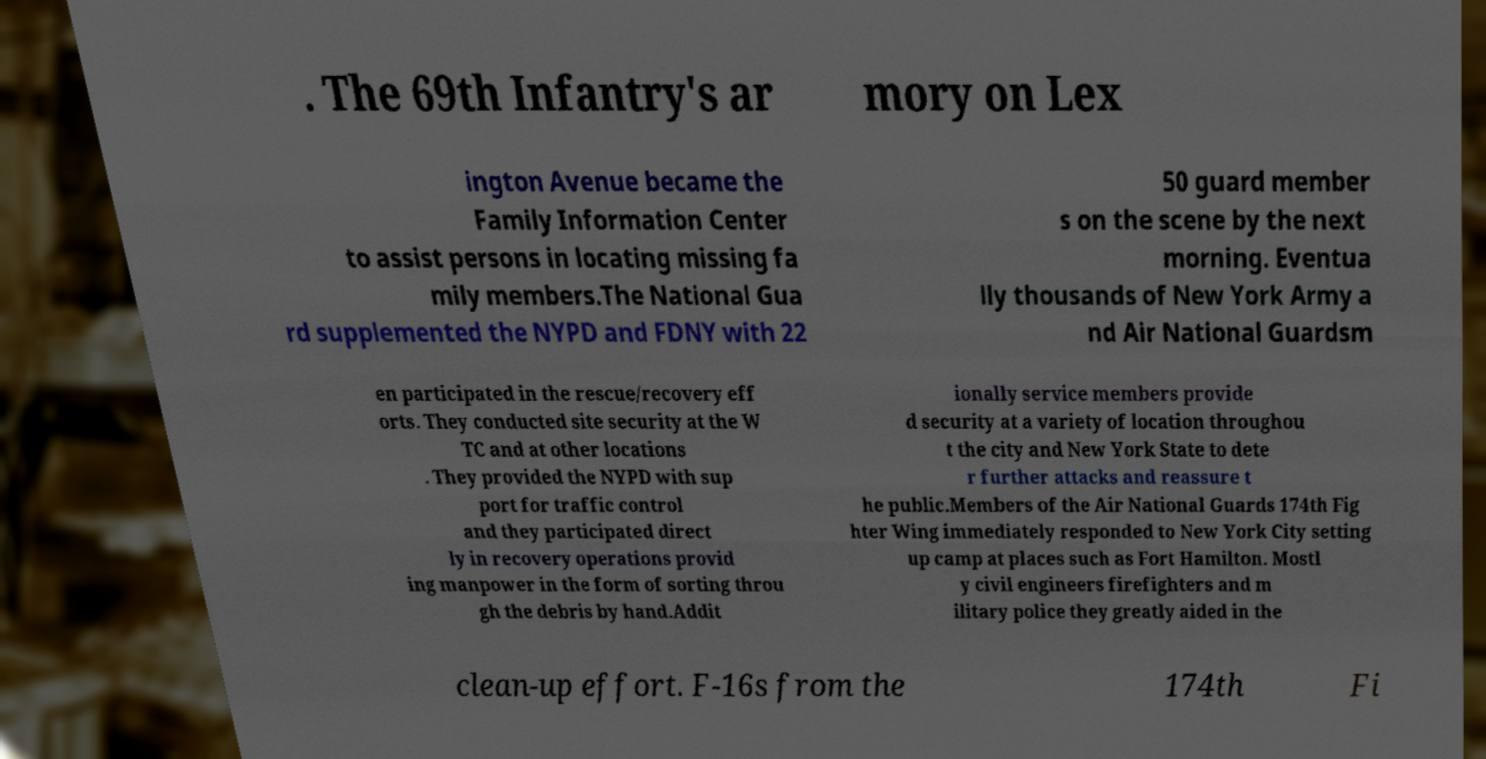Could you assist in decoding the text presented in this image and type it out clearly? . The 69th Infantry's ar mory on Lex ington Avenue became the Family Information Center to assist persons in locating missing fa mily members.The National Gua rd supplemented the NYPD and FDNY with 22 50 guard member s on the scene by the next morning. Eventua lly thousands of New York Army a nd Air National Guardsm en participated in the rescue/recovery eff orts. They conducted site security at the W TC and at other locations . They provided the NYPD with sup port for traffic control and they participated direct ly in recovery operations provid ing manpower in the form of sorting throu gh the debris by hand.Addit ionally service members provide d security at a variety of location throughou t the city and New York State to dete r further attacks and reassure t he public.Members of the Air National Guards 174th Fig hter Wing immediately responded to New York City setting up camp at places such as Fort Hamilton. Mostl y civil engineers firefighters and m ilitary police they greatly aided in the clean-up effort. F-16s from the 174th Fi 